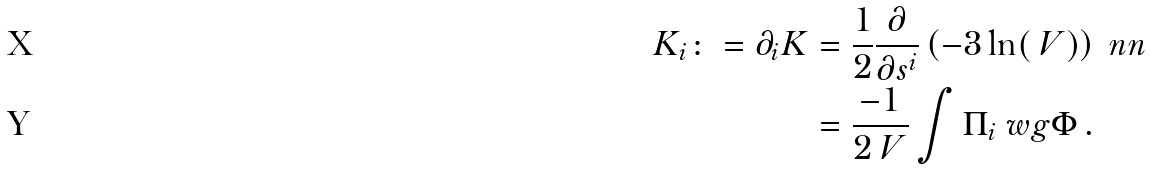<formula> <loc_0><loc_0><loc_500><loc_500>K _ { i } \colon = \partial _ { i } K & = \frac { 1 } { 2 } \frac { \partial } { \partial s ^ { i } } \left ( - 3 \ln ( \ V ) \right ) \ n n \\ & = \frac { - 1 } { 2 \ V } \int \Pi _ { i } \ w g \Phi \, .</formula> 